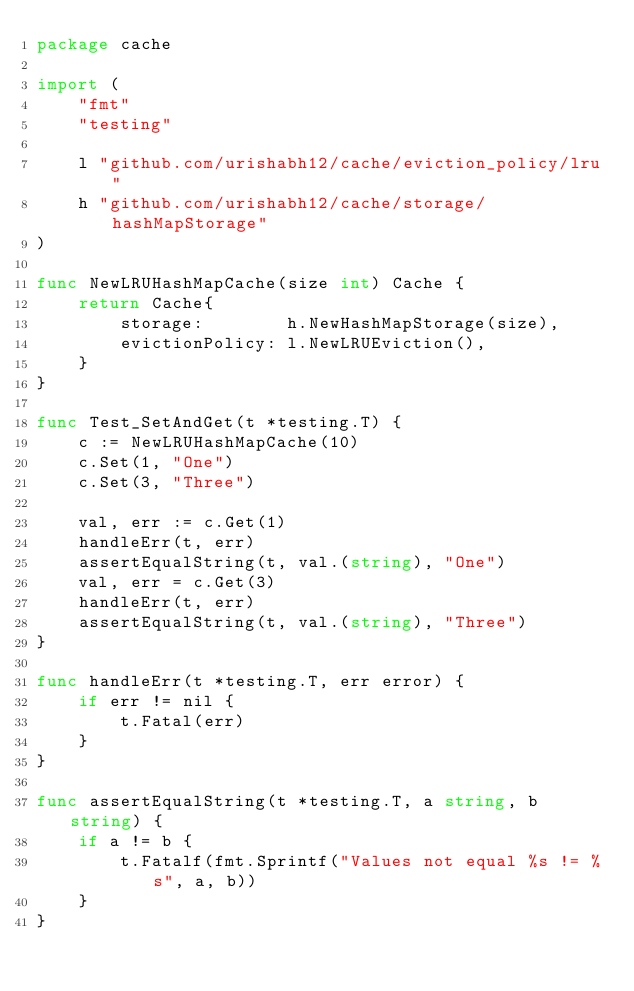Convert code to text. <code><loc_0><loc_0><loc_500><loc_500><_Go_>package cache

import (
	"fmt"
	"testing"

	l "github.com/urishabh12/cache/eviction_policy/lru"
	h "github.com/urishabh12/cache/storage/hashMapStorage"
)

func NewLRUHashMapCache(size int) Cache {
	return Cache{
		storage:        h.NewHashMapStorage(size),
		evictionPolicy: l.NewLRUEviction(),
	}
}

func Test_SetAndGet(t *testing.T) {
	c := NewLRUHashMapCache(10)
	c.Set(1, "One")
	c.Set(3, "Three")

	val, err := c.Get(1)
	handleErr(t, err)
	assertEqualString(t, val.(string), "One")
	val, err = c.Get(3)
	handleErr(t, err)
	assertEqualString(t, val.(string), "Three")
}

func handleErr(t *testing.T, err error) {
	if err != nil {
		t.Fatal(err)
	}
}

func assertEqualString(t *testing.T, a string, b string) {
	if a != b {
		t.Fatalf(fmt.Sprintf("Values not equal %s != %s", a, b))
	}
}
</code> 